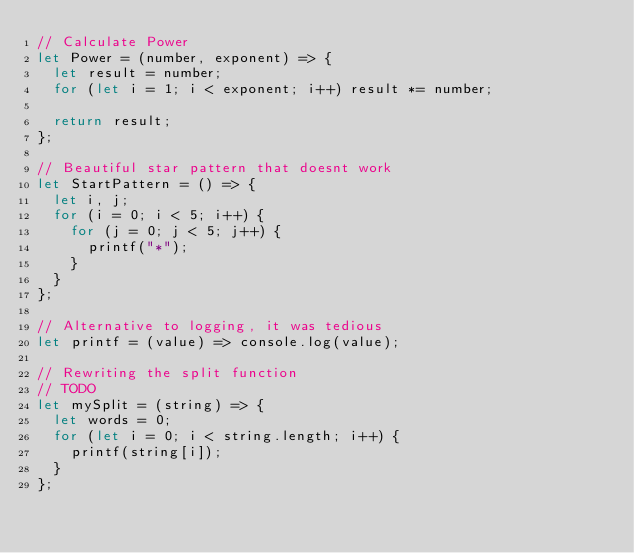Convert code to text. <code><loc_0><loc_0><loc_500><loc_500><_JavaScript_>// Calculate Power
let Power = (number, exponent) => {
  let result = number;
  for (let i = 1; i < exponent; i++) result *= number;

  return result;
};

// Beautiful star pattern that doesnt work
let StartPattern = () => {
  let i, j;
  for (i = 0; i < 5; i++) {
    for (j = 0; j < 5; j++) {
      printf("*");
    }
  }
};

// Alternative to logging, it was tedious
let printf = (value) => console.log(value);

// Rewriting the split function
// TODO
let mySplit = (string) => {
  let words = 0;
  for (let i = 0; i < string.length; i++) {
    printf(string[i]);
  }
};
</code> 